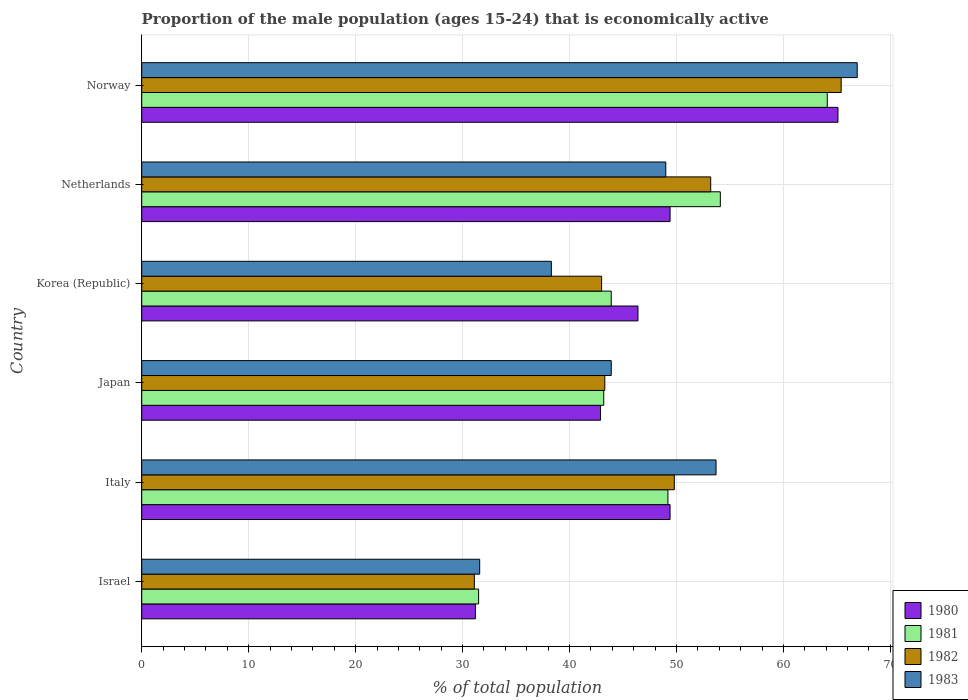How many bars are there on the 5th tick from the bottom?
Offer a terse response. 4. In how many cases, is the number of bars for a given country not equal to the number of legend labels?
Give a very brief answer. 0. What is the proportion of the male population that is economically active in 1982 in Italy?
Your answer should be compact. 49.8. Across all countries, what is the maximum proportion of the male population that is economically active in 1983?
Give a very brief answer. 66.9. Across all countries, what is the minimum proportion of the male population that is economically active in 1982?
Give a very brief answer. 31.1. In which country was the proportion of the male population that is economically active in 1983 minimum?
Your response must be concise. Israel. What is the total proportion of the male population that is economically active in 1983 in the graph?
Make the answer very short. 283.4. What is the difference between the proportion of the male population that is economically active in 1981 in Israel and that in Korea (Republic)?
Make the answer very short. -12.4. What is the difference between the proportion of the male population that is economically active in 1983 in Japan and the proportion of the male population that is economically active in 1980 in Korea (Republic)?
Offer a very short reply. -2.5. What is the average proportion of the male population that is economically active in 1981 per country?
Your response must be concise. 47.67. In how many countries, is the proportion of the male population that is economically active in 1983 greater than 64 %?
Keep it short and to the point. 1. What is the ratio of the proportion of the male population that is economically active in 1982 in Japan to that in Norway?
Provide a short and direct response. 0.66. Is the proportion of the male population that is economically active in 1983 in Japan less than that in Netherlands?
Make the answer very short. Yes. Is the difference between the proportion of the male population that is economically active in 1981 in Korea (Republic) and Norway greater than the difference between the proportion of the male population that is economically active in 1980 in Korea (Republic) and Norway?
Provide a short and direct response. No. What is the difference between the highest and the second highest proportion of the male population that is economically active in 1980?
Give a very brief answer. 15.7. What is the difference between the highest and the lowest proportion of the male population that is economically active in 1981?
Offer a very short reply. 32.6. Is it the case that in every country, the sum of the proportion of the male population that is economically active in 1983 and proportion of the male population that is economically active in 1980 is greater than the proportion of the male population that is economically active in 1982?
Keep it short and to the point. Yes. How many bars are there?
Provide a short and direct response. 24. What is the difference between two consecutive major ticks on the X-axis?
Your answer should be compact. 10. Are the values on the major ticks of X-axis written in scientific E-notation?
Keep it short and to the point. No. Does the graph contain grids?
Offer a very short reply. Yes. Where does the legend appear in the graph?
Provide a succinct answer. Bottom right. How many legend labels are there?
Your answer should be compact. 4. What is the title of the graph?
Ensure brevity in your answer.  Proportion of the male population (ages 15-24) that is economically active. Does "2001" appear as one of the legend labels in the graph?
Ensure brevity in your answer.  No. What is the label or title of the X-axis?
Make the answer very short. % of total population. What is the label or title of the Y-axis?
Your answer should be compact. Country. What is the % of total population of 1980 in Israel?
Provide a short and direct response. 31.2. What is the % of total population in 1981 in Israel?
Ensure brevity in your answer.  31.5. What is the % of total population of 1982 in Israel?
Offer a very short reply. 31.1. What is the % of total population of 1983 in Israel?
Offer a very short reply. 31.6. What is the % of total population of 1980 in Italy?
Ensure brevity in your answer.  49.4. What is the % of total population of 1981 in Italy?
Provide a short and direct response. 49.2. What is the % of total population in 1982 in Italy?
Make the answer very short. 49.8. What is the % of total population in 1983 in Italy?
Give a very brief answer. 53.7. What is the % of total population of 1980 in Japan?
Provide a succinct answer. 42.9. What is the % of total population in 1981 in Japan?
Your answer should be very brief. 43.2. What is the % of total population in 1982 in Japan?
Your answer should be compact. 43.3. What is the % of total population in 1983 in Japan?
Offer a very short reply. 43.9. What is the % of total population of 1980 in Korea (Republic)?
Offer a terse response. 46.4. What is the % of total population in 1981 in Korea (Republic)?
Ensure brevity in your answer.  43.9. What is the % of total population in 1983 in Korea (Republic)?
Keep it short and to the point. 38.3. What is the % of total population in 1980 in Netherlands?
Offer a very short reply. 49.4. What is the % of total population of 1981 in Netherlands?
Make the answer very short. 54.1. What is the % of total population of 1982 in Netherlands?
Make the answer very short. 53.2. What is the % of total population in 1983 in Netherlands?
Offer a terse response. 49. What is the % of total population of 1980 in Norway?
Your response must be concise. 65.1. What is the % of total population of 1981 in Norway?
Ensure brevity in your answer.  64.1. What is the % of total population in 1982 in Norway?
Provide a succinct answer. 65.4. What is the % of total population of 1983 in Norway?
Offer a terse response. 66.9. Across all countries, what is the maximum % of total population of 1980?
Offer a terse response. 65.1. Across all countries, what is the maximum % of total population in 1981?
Provide a short and direct response. 64.1. Across all countries, what is the maximum % of total population in 1982?
Offer a terse response. 65.4. Across all countries, what is the maximum % of total population of 1983?
Give a very brief answer. 66.9. Across all countries, what is the minimum % of total population in 1980?
Ensure brevity in your answer.  31.2. Across all countries, what is the minimum % of total population in 1981?
Offer a very short reply. 31.5. Across all countries, what is the minimum % of total population of 1982?
Your response must be concise. 31.1. Across all countries, what is the minimum % of total population of 1983?
Your answer should be compact. 31.6. What is the total % of total population of 1980 in the graph?
Give a very brief answer. 284.4. What is the total % of total population in 1981 in the graph?
Ensure brevity in your answer.  286. What is the total % of total population in 1982 in the graph?
Offer a terse response. 285.8. What is the total % of total population in 1983 in the graph?
Provide a short and direct response. 283.4. What is the difference between the % of total population of 1980 in Israel and that in Italy?
Provide a succinct answer. -18.2. What is the difference between the % of total population of 1981 in Israel and that in Italy?
Keep it short and to the point. -17.7. What is the difference between the % of total population of 1982 in Israel and that in Italy?
Offer a very short reply. -18.7. What is the difference between the % of total population in 1983 in Israel and that in Italy?
Give a very brief answer. -22.1. What is the difference between the % of total population in 1980 in Israel and that in Japan?
Give a very brief answer. -11.7. What is the difference between the % of total population in 1980 in Israel and that in Korea (Republic)?
Give a very brief answer. -15.2. What is the difference between the % of total population of 1981 in Israel and that in Korea (Republic)?
Give a very brief answer. -12.4. What is the difference between the % of total population of 1983 in Israel and that in Korea (Republic)?
Offer a terse response. -6.7. What is the difference between the % of total population in 1980 in Israel and that in Netherlands?
Your answer should be very brief. -18.2. What is the difference between the % of total population of 1981 in Israel and that in Netherlands?
Give a very brief answer. -22.6. What is the difference between the % of total population of 1982 in Israel and that in Netherlands?
Offer a terse response. -22.1. What is the difference between the % of total population in 1983 in Israel and that in Netherlands?
Provide a short and direct response. -17.4. What is the difference between the % of total population in 1980 in Israel and that in Norway?
Provide a short and direct response. -33.9. What is the difference between the % of total population in 1981 in Israel and that in Norway?
Ensure brevity in your answer.  -32.6. What is the difference between the % of total population in 1982 in Israel and that in Norway?
Your answer should be compact. -34.3. What is the difference between the % of total population of 1983 in Israel and that in Norway?
Your answer should be compact. -35.3. What is the difference between the % of total population of 1981 in Italy and that in Japan?
Keep it short and to the point. 6. What is the difference between the % of total population in 1980 in Italy and that in Korea (Republic)?
Your response must be concise. 3. What is the difference between the % of total population of 1982 in Italy and that in Korea (Republic)?
Offer a terse response. 6.8. What is the difference between the % of total population of 1983 in Italy and that in Korea (Republic)?
Provide a short and direct response. 15.4. What is the difference between the % of total population of 1980 in Italy and that in Netherlands?
Ensure brevity in your answer.  0. What is the difference between the % of total population in 1981 in Italy and that in Netherlands?
Provide a short and direct response. -4.9. What is the difference between the % of total population of 1982 in Italy and that in Netherlands?
Ensure brevity in your answer.  -3.4. What is the difference between the % of total population in 1980 in Italy and that in Norway?
Your answer should be compact. -15.7. What is the difference between the % of total population of 1981 in Italy and that in Norway?
Offer a very short reply. -14.9. What is the difference between the % of total population in 1982 in Italy and that in Norway?
Your answer should be compact. -15.6. What is the difference between the % of total population of 1983 in Italy and that in Norway?
Your answer should be compact. -13.2. What is the difference between the % of total population in 1980 in Japan and that in Korea (Republic)?
Your answer should be very brief. -3.5. What is the difference between the % of total population of 1981 in Japan and that in Korea (Republic)?
Make the answer very short. -0.7. What is the difference between the % of total population in 1983 in Japan and that in Korea (Republic)?
Ensure brevity in your answer.  5.6. What is the difference between the % of total population in 1983 in Japan and that in Netherlands?
Your answer should be compact. -5.1. What is the difference between the % of total population of 1980 in Japan and that in Norway?
Make the answer very short. -22.2. What is the difference between the % of total population of 1981 in Japan and that in Norway?
Offer a very short reply. -20.9. What is the difference between the % of total population in 1982 in Japan and that in Norway?
Provide a short and direct response. -22.1. What is the difference between the % of total population of 1983 in Korea (Republic) and that in Netherlands?
Your answer should be compact. -10.7. What is the difference between the % of total population in 1980 in Korea (Republic) and that in Norway?
Offer a terse response. -18.7. What is the difference between the % of total population in 1981 in Korea (Republic) and that in Norway?
Your response must be concise. -20.2. What is the difference between the % of total population of 1982 in Korea (Republic) and that in Norway?
Provide a short and direct response. -22.4. What is the difference between the % of total population in 1983 in Korea (Republic) and that in Norway?
Offer a terse response. -28.6. What is the difference between the % of total population in 1980 in Netherlands and that in Norway?
Your response must be concise. -15.7. What is the difference between the % of total population of 1982 in Netherlands and that in Norway?
Your response must be concise. -12.2. What is the difference between the % of total population in 1983 in Netherlands and that in Norway?
Keep it short and to the point. -17.9. What is the difference between the % of total population in 1980 in Israel and the % of total population in 1982 in Italy?
Make the answer very short. -18.6. What is the difference between the % of total population in 1980 in Israel and the % of total population in 1983 in Italy?
Provide a succinct answer. -22.5. What is the difference between the % of total population in 1981 in Israel and the % of total population in 1982 in Italy?
Provide a succinct answer. -18.3. What is the difference between the % of total population of 1981 in Israel and the % of total population of 1983 in Italy?
Ensure brevity in your answer.  -22.2. What is the difference between the % of total population of 1982 in Israel and the % of total population of 1983 in Italy?
Keep it short and to the point. -22.6. What is the difference between the % of total population in 1980 in Israel and the % of total population in 1981 in Japan?
Keep it short and to the point. -12. What is the difference between the % of total population of 1980 in Israel and the % of total population of 1983 in Japan?
Provide a succinct answer. -12.7. What is the difference between the % of total population in 1981 in Israel and the % of total population in 1983 in Japan?
Your answer should be compact. -12.4. What is the difference between the % of total population in 1980 in Israel and the % of total population in 1981 in Korea (Republic)?
Keep it short and to the point. -12.7. What is the difference between the % of total population in 1980 in Israel and the % of total population in 1982 in Korea (Republic)?
Your answer should be compact. -11.8. What is the difference between the % of total population of 1980 in Israel and the % of total population of 1983 in Korea (Republic)?
Offer a terse response. -7.1. What is the difference between the % of total population in 1981 in Israel and the % of total population in 1982 in Korea (Republic)?
Give a very brief answer. -11.5. What is the difference between the % of total population of 1981 in Israel and the % of total population of 1983 in Korea (Republic)?
Keep it short and to the point. -6.8. What is the difference between the % of total population in 1980 in Israel and the % of total population in 1981 in Netherlands?
Your answer should be compact. -22.9. What is the difference between the % of total population in 1980 in Israel and the % of total population in 1983 in Netherlands?
Provide a succinct answer. -17.8. What is the difference between the % of total population in 1981 in Israel and the % of total population in 1982 in Netherlands?
Ensure brevity in your answer.  -21.7. What is the difference between the % of total population of 1981 in Israel and the % of total population of 1983 in Netherlands?
Make the answer very short. -17.5. What is the difference between the % of total population in 1982 in Israel and the % of total population in 1983 in Netherlands?
Give a very brief answer. -17.9. What is the difference between the % of total population of 1980 in Israel and the % of total population of 1981 in Norway?
Provide a short and direct response. -32.9. What is the difference between the % of total population of 1980 in Israel and the % of total population of 1982 in Norway?
Keep it short and to the point. -34.2. What is the difference between the % of total population of 1980 in Israel and the % of total population of 1983 in Norway?
Ensure brevity in your answer.  -35.7. What is the difference between the % of total population of 1981 in Israel and the % of total population of 1982 in Norway?
Offer a very short reply. -33.9. What is the difference between the % of total population of 1981 in Israel and the % of total population of 1983 in Norway?
Offer a very short reply. -35.4. What is the difference between the % of total population in 1982 in Israel and the % of total population in 1983 in Norway?
Your answer should be compact. -35.8. What is the difference between the % of total population of 1980 in Italy and the % of total population of 1981 in Japan?
Give a very brief answer. 6.2. What is the difference between the % of total population in 1980 in Italy and the % of total population in 1982 in Japan?
Ensure brevity in your answer.  6.1. What is the difference between the % of total population of 1980 in Italy and the % of total population of 1982 in Korea (Republic)?
Make the answer very short. 6.4. What is the difference between the % of total population in 1980 in Italy and the % of total population in 1983 in Korea (Republic)?
Offer a very short reply. 11.1. What is the difference between the % of total population in 1981 in Italy and the % of total population in 1983 in Korea (Republic)?
Provide a succinct answer. 10.9. What is the difference between the % of total population of 1982 in Italy and the % of total population of 1983 in Netherlands?
Make the answer very short. 0.8. What is the difference between the % of total population in 1980 in Italy and the % of total population in 1981 in Norway?
Make the answer very short. -14.7. What is the difference between the % of total population of 1980 in Italy and the % of total population of 1983 in Norway?
Your response must be concise. -17.5. What is the difference between the % of total population of 1981 in Italy and the % of total population of 1982 in Norway?
Give a very brief answer. -16.2. What is the difference between the % of total population in 1981 in Italy and the % of total population in 1983 in Norway?
Your answer should be compact. -17.7. What is the difference between the % of total population of 1982 in Italy and the % of total population of 1983 in Norway?
Your answer should be compact. -17.1. What is the difference between the % of total population in 1980 in Japan and the % of total population in 1982 in Korea (Republic)?
Make the answer very short. -0.1. What is the difference between the % of total population in 1980 in Japan and the % of total population in 1983 in Korea (Republic)?
Make the answer very short. 4.6. What is the difference between the % of total population in 1981 in Japan and the % of total population in 1982 in Korea (Republic)?
Your answer should be very brief. 0.2. What is the difference between the % of total population in 1982 in Japan and the % of total population in 1983 in Korea (Republic)?
Your answer should be compact. 5. What is the difference between the % of total population of 1980 in Japan and the % of total population of 1981 in Netherlands?
Provide a succinct answer. -11.2. What is the difference between the % of total population in 1980 in Japan and the % of total population in 1982 in Netherlands?
Provide a short and direct response. -10.3. What is the difference between the % of total population in 1980 in Japan and the % of total population in 1983 in Netherlands?
Your answer should be very brief. -6.1. What is the difference between the % of total population of 1981 in Japan and the % of total population of 1983 in Netherlands?
Provide a succinct answer. -5.8. What is the difference between the % of total population in 1982 in Japan and the % of total population in 1983 in Netherlands?
Offer a very short reply. -5.7. What is the difference between the % of total population in 1980 in Japan and the % of total population in 1981 in Norway?
Provide a short and direct response. -21.2. What is the difference between the % of total population of 1980 in Japan and the % of total population of 1982 in Norway?
Your response must be concise. -22.5. What is the difference between the % of total population of 1980 in Japan and the % of total population of 1983 in Norway?
Keep it short and to the point. -24. What is the difference between the % of total population in 1981 in Japan and the % of total population in 1982 in Norway?
Keep it short and to the point. -22.2. What is the difference between the % of total population in 1981 in Japan and the % of total population in 1983 in Norway?
Offer a very short reply. -23.7. What is the difference between the % of total population in 1982 in Japan and the % of total population in 1983 in Norway?
Ensure brevity in your answer.  -23.6. What is the difference between the % of total population of 1980 in Korea (Republic) and the % of total population of 1981 in Netherlands?
Make the answer very short. -7.7. What is the difference between the % of total population in 1982 in Korea (Republic) and the % of total population in 1983 in Netherlands?
Your response must be concise. -6. What is the difference between the % of total population of 1980 in Korea (Republic) and the % of total population of 1981 in Norway?
Make the answer very short. -17.7. What is the difference between the % of total population of 1980 in Korea (Republic) and the % of total population of 1983 in Norway?
Provide a succinct answer. -20.5. What is the difference between the % of total population in 1981 in Korea (Republic) and the % of total population in 1982 in Norway?
Ensure brevity in your answer.  -21.5. What is the difference between the % of total population in 1981 in Korea (Republic) and the % of total population in 1983 in Norway?
Your answer should be compact. -23. What is the difference between the % of total population in 1982 in Korea (Republic) and the % of total population in 1983 in Norway?
Give a very brief answer. -23.9. What is the difference between the % of total population in 1980 in Netherlands and the % of total population in 1981 in Norway?
Give a very brief answer. -14.7. What is the difference between the % of total population of 1980 in Netherlands and the % of total population of 1982 in Norway?
Offer a very short reply. -16. What is the difference between the % of total population of 1980 in Netherlands and the % of total population of 1983 in Norway?
Ensure brevity in your answer.  -17.5. What is the difference between the % of total population in 1982 in Netherlands and the % of total population in 1983 in Norway?
Your answer should be compact. -13.7. What is the average % of total population in 1980 per country?
Your answer should be very brief. 47.4. What is the average % of total population in 1981 per country?
Offer a very short reply. 47.67. What is the average % of total population of 1982 per country?
Provide a succinct answer. 47.63. What is the average % of total population of 1983 per country?
Make the answer very short. 47.23. What is the difference between the % of total population of 1980 and % of total population of 1981 in Israel?
Ensure brevity in your answer.  -0.3. What is the difference between the % of total population of 1980 and % of total population of 1982 in Israel?
Offer a very short reply. 0.1. What is the difference between the % of total population in 1981 and % of total population in 1982 in Israel?
Provide a short and direct response. 0.4. What is the difference between the % of total population of 1980 and % of total population of 1981 in Italy?
Keep it short and to the point. 0.2. What is the difference between the % of total population in 1980 and % of total population in 1982 in Italy?
Offer a very short reply. -0.4. What is the difference between the % of total population in 1981 and % of total population in 1982 in Italy?
Give a very brief answer. -0.6. What is the difference between the % of total population of 1981 and % of total population of 1983 in Italy?
Offer a terse response. -4.5. What is the difference between the % of total population of 1982 and % of total population of 1983 in Italy?
Keep it short and to the point. -3.9. What is the difference between the % of total population of 1980 and % of total population of 1982 in Japan?
Give a very brief answer. -0.4. What is the difference between the % of total population of 1980 and % of total population of 1981 in Korea (Republic)?
Provide a short and direct response. 2.5. What is the difference between the % of total population in 1981 and % of total population in 1983 in Korea (Republic)?
Your answer should be compact. 5.6. What is the difference between the % of total population of 1980 and % of total population of 1982 in Netherlands?
Your response must be concise. -3.8. What is the difference between the % of total population of 1980 and % of total population of 1983 in Netherlands?
Make the answer very short. 0.4. What is the difference between the % of total population in 1981 and % of total population in 1983 in Netherlands?
Ensure brevity in your answer.  5.1. What is the difference between the % of total population in 1980 and % of total population in 1982 in Norway?
Provide a short and direct response. -0.3. What is the ratio of the % of total population of 1980 in Israel to that in Italy?
Offer a terse response. 0.63. What is the ratio of the % of total population in 1981 in Israel to that in Italy?
Your answer should be very brief. 0.64. What is the ratio of the % of total population in 1982 in Israel to that in Italy?
Your answer should be very brief. 0.62. What is the ratio of the % of total population of 1983 in Israel to that in Italy?
Make the answer very short. 0.59. What is the ratio of the % of total population in 1980 in Israel to that in Japan?
Your answer should be compact. 0.73. What is the ratio of the % of total population in 1981 in Israel to that in Japan?
Keep it short and to the point. 0.73. What is the ratio of the % of total population of 1982 in Israel to that in Japan?
Provide a succinct answer. 0.72. What is the ratio of the % of total population of 1983 in Israel to that in Japan?
Offer a terse response. 0.72. What is the ratio of the % of total population of 1980 in Israel to that in Korea (Republic)?
Make the answer very short. 0.67. What is the ratio of the % of total population in 1981 in Israel to that in Korea (Republic)?
Keep it short and to the point. 0.72. What is the ratio of the % of total population of 1982 in Israel to that in Korea (Republic)?
Offer a very short reply. 0.72. What is the ratio of the % of total population of 1983 in Israel to that in Korea (Republic)?
Make the answer very short. 0.83. What is the ratio of the % of total population of 1980 in Israel to that in Netherlands?
Provide a short and direct response. 0.63. What is the ratio of the % of total population in 1981 in Israel to that in Netherlands?
Provide a short and direct response. 0.58. What is the ratio of the % of total population in 1982 in Israel to that in Netherlands?
Offer a terse response. 0.58. What is the ratio of the % of total population of 1983 in Israel to that in Netherlands?
Keep it short and to the point. 0.64. What is the ratio of the % of total population in 1980 in Israel to that in Norway?
Offer a very short reply. 0.48. What is the ratio of the % of total population of 1981 in Israel to that in Norway?
Offer a very short reply. 0.49. What is the ratio of the % of total population in 1982 in Israel to that in Norway?
Your answer should be compact. 0.48. What is the ratio of the % of total population of 1983 in Israel to that in Norway?
Ensure brevity in your answer.  0.47. What is the ratio of the % of total population of 1980 in Italy to that in Japan?
Give a very brief answer. 1.15. What is the ratio of the % of total population in 1981 in Italy to that in Japan?
Provide a short and direct response. 1.14. What is the ratio of the % of total population of 1982 in Italy to that in Japan?
Make the answer very short. 1.15. What is the ratio of the % of total population in 1983 in Italy to that in Japan?
Give a very brief answer. 1.22. What is the ratio of the % of total population of 1980 in Italy to that in Korea (Republic)?
Give a very brief answer. 1.06. What is the ratio of the % of total population in 1981 in Italy to that in Korea (Republic)?
Your response must be concise. 1.12. What is the ratio of the % of total population of 1982 in Italy to that in Korea (Republic)?
Your response must be concise. 1.16. What is the ratio of the % of total population of 1983 in Italy to that in Korea (Republic)?
Offer a very short reply. 1.4. What is the ratio of the % of total population of 1981 in Italy to that in Netherlands?
Your answer should be compact. 0.91. What is the ratio of the % of total population in 1982 in Italy to that in Netherlands?
Your answer should be compact. 0.94. What is the ratio of the % of total population in 1983 in Italy to that in Netherlands?
Ensure brevity in your answer.  1.1. What is the ratio of the % of total population in 1980 in Italy to that in Norway?
Provide a short and direct response. 0.76. What is the ratio of the % of total population of 1981 in Italy to that in Norway?
Your response must be concise. 0.77. What is the ratio of the % of total population of 1982 in Italy to that in Norway?
Keep it short and to the point. 0.76. What is the ratio of the % of total population in 1983 in Italy to that in Norway?
Provide a short and direct response. 0.8. What is the ratio of the % of total population of 1980 in Japan to that in Korea (Republic)?
Keep it short and to the point. 0.92. What is the ratio of the % of total population in 1981 in Japan to that in Korea (Republic)?
Ensure brevity in your answer.  0.98. What is the ratio of the % of total population of 1982 in Japan to that in Korea (Republic)?
Your answer should be very brief. 1.01. What is the ratio of the % of total population of 1983 in Japan to that in Korea (Republic)?
Give a very brief answer. 1.15. What is the ratio of the % of total population in 1980 in Japan to that in Netherlands?
Your answer should be very brief. 0.87. What is the ratio of the % of total population of 1981 in Japan to that in Netherlands?
Provide a succinct answer. 0.8. What is the ratio of the % of total population in 1982 in Japan to that in Netherlands?
Your answer should be very brief. 0.81. What is the ratio of the % of total population of 1983 in Japan to that in Netherlands?
Make the answer very short. 0.9. What is the ratio of the % of total population in 1980 in Japan to that in Norway?
Keep it short and to the point. 0.66. What is the ratio of the % of total population in 1981 in Japan to that in Norway?
Make the answer very short. 0.67. What is the ratio of the % of total population in 1982 in Japan to that in Norway?
Offer a very short reply. 0.66. What is the ratio of the % of total population of 1983 in Japan to that in Norway?
Keep it short and to the point. 0.66. What is the ratio of the % of total population of 1980 in Korea (Republic) to that in Netherlands?
Give a very brief answer. 0.94. What is the ratio of the % of total population of 1981 in Korea (Republic) to that in Netherlands?
Your response must be concise. 0.81. What is the ratio of the % of total population of 1982 in Korea (Republic) to that in Netherlands?
Your answer should be very brief. 0.81. What is the ratio of the % of total population of 1983 in Korea (Republic) to that in Netherlands?
Your response must be concise. 0.78. What is the ratio of the % of total population of 1980 in Korea (Republic) to that in Norway?
Ensure brevity in your answer.  0.71. What is the ratio of the % of total population of 1981 in Korea (Republic) to that in Norway?
Your answer should be very brief. 0.68. What is the ratio of the % of total population in 1982 in Korea (Republic) to that in Norway?
Your answer should be very brief. 0.66. What is the ratio of the % of total population of 1983 in Korea (Republic) to that in Norway?
Keep it short and to the point. 0.57. What is the ratio of the % of total population of 1980 in Netherlands to that in Norway?
Make the answer very short. 0.76. What is the ratio of the % of total population in 1981 in Netherlands to that in Norway?
Provide a short and direct response. 0.84. What is the ratio of the % of total population in 1982 in Netherlands to that in Norway?
Provide a short and direct response. 0.81. What is the ratio of the % of total population of 1983 in Netherlands to that in Norway?
Keep it short and to the point. 0.73. What is the difference between the highest and the second highest % of total population in 1982?
Make the answer very short. 12.2. What is the difference between the highest and the second highest % of total population in 1983?
Give a very brief answer. 13.2. What is the difference between the highest and the lowest % of total population in 1980?
Provide a short and direct response. 33.9. What is the difference between the highest and the lowest % of total population in 1981?
Make the answer very short. 32.6. What is the difference between the highest and the lowest % of total population in 1982?
Offer a terse response. 34.3. What is the difference between the highest and the lowest % of total population of 1983?
Your response must be concise. 35.3. 